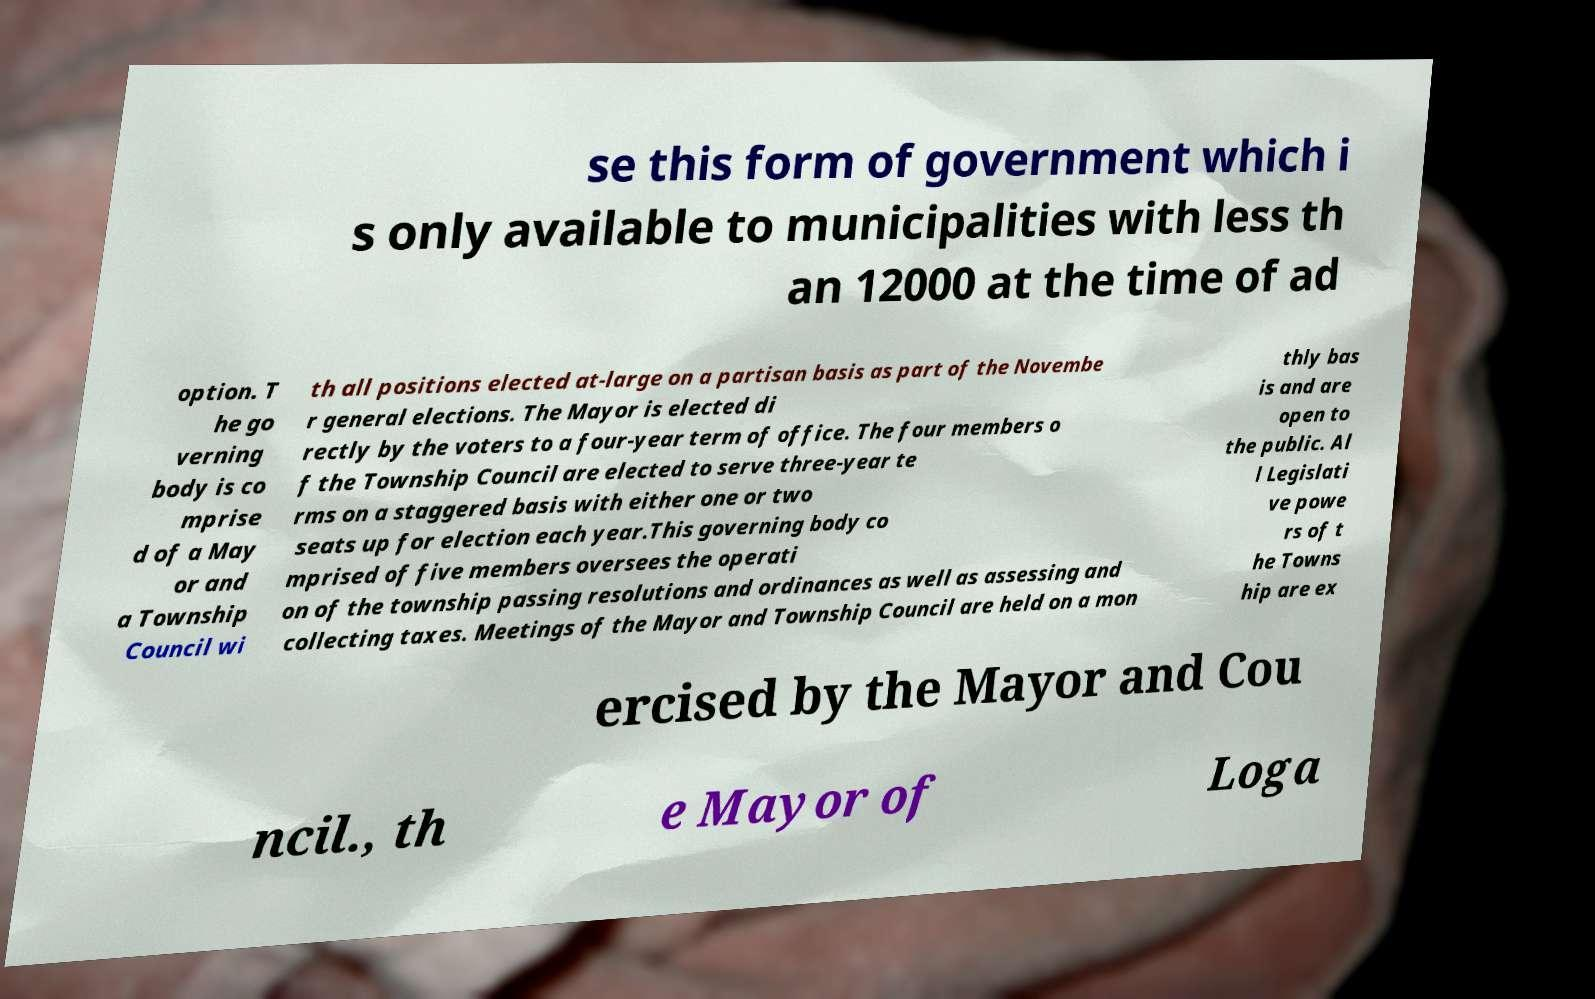Can you read and provide the text displayed in the image?This photo seems to have some interesting text. Can you extract and type it out for me? se this form of government which i s only available to municipalities with less th an 12000 at the time of ad option. T he go verning body is co mprise d of a May or and a Township Council wi th all positions elected at-large on a partisan basis as part of the Novembe r general elections. The Mayor is elected di rectly by the voters to a four-year term of office. The four members o f the Township Council are elected to serve three-year te rms on a staggered basis with either one or two seats up for election each year.This governing body co mprised of five members oversees the operati on of the township passing resolutions and ordinances as well as assessing and collecting taxes. Meetings of the Mayor and Township Council are held on a mon thly bas is and are open to the public. Al l Legislati ve powe rs of t he Towns hip are ex ercised by the Mayor and Cou ncil., th e Mayor of Loga 